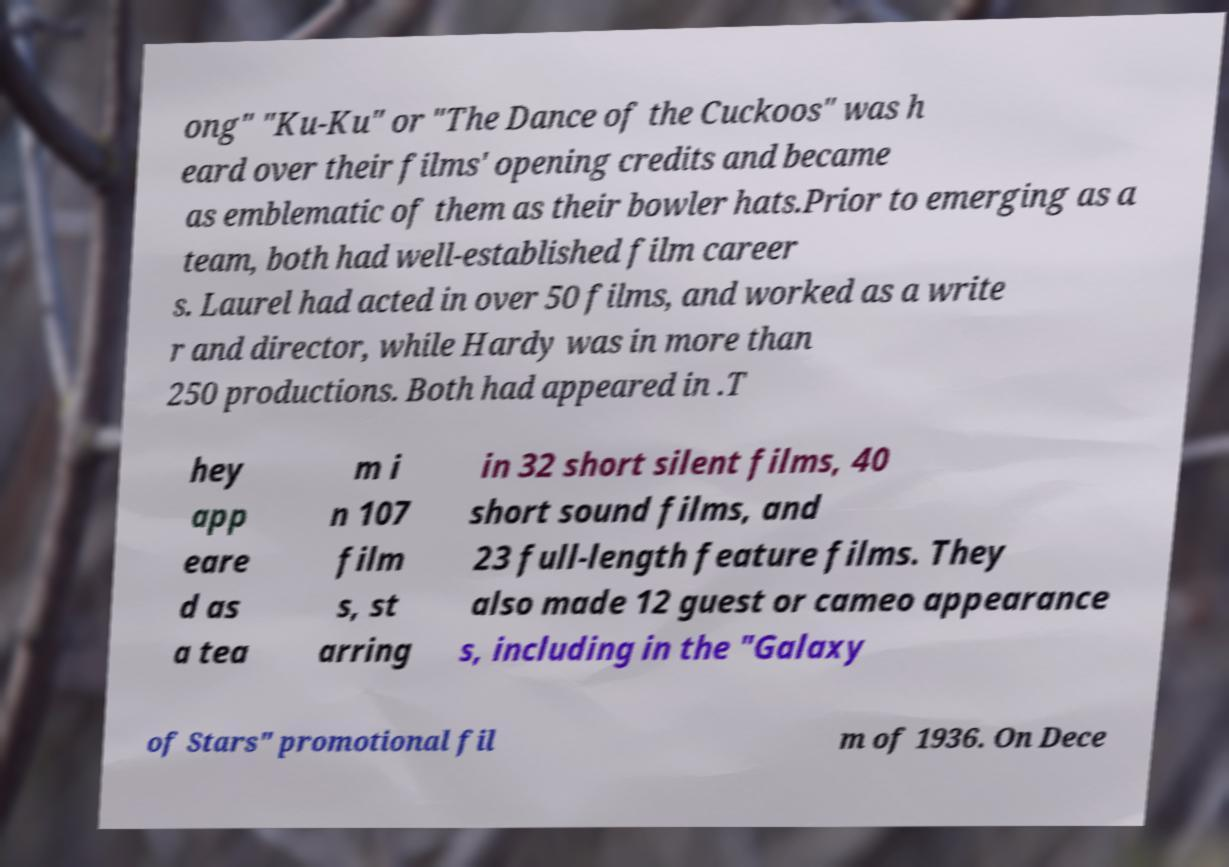For documentation purposes, I need the text within this image transcribed. Could you provide that? ong" "Ku-Ku" or "The Dance of the Cuckoos" was h eard over their films' opening credits and became as emblematic of them as their bowler hats.Prior to emerging as a team, both had well-established film career s. Laurel had acted in over 50 films, and worked as a write r and director, while Hardy was in more than 250 productions. Both had appeared in .T hey app eare d as a tea m i n 107 film s, st arring in 32 short silent films, 40 short sound films, and 23 full-length feature films. They also made 12 guest or cameo appearance s, including in the "Galaxy of Stars" promotional fil m of 1936. On Dece 